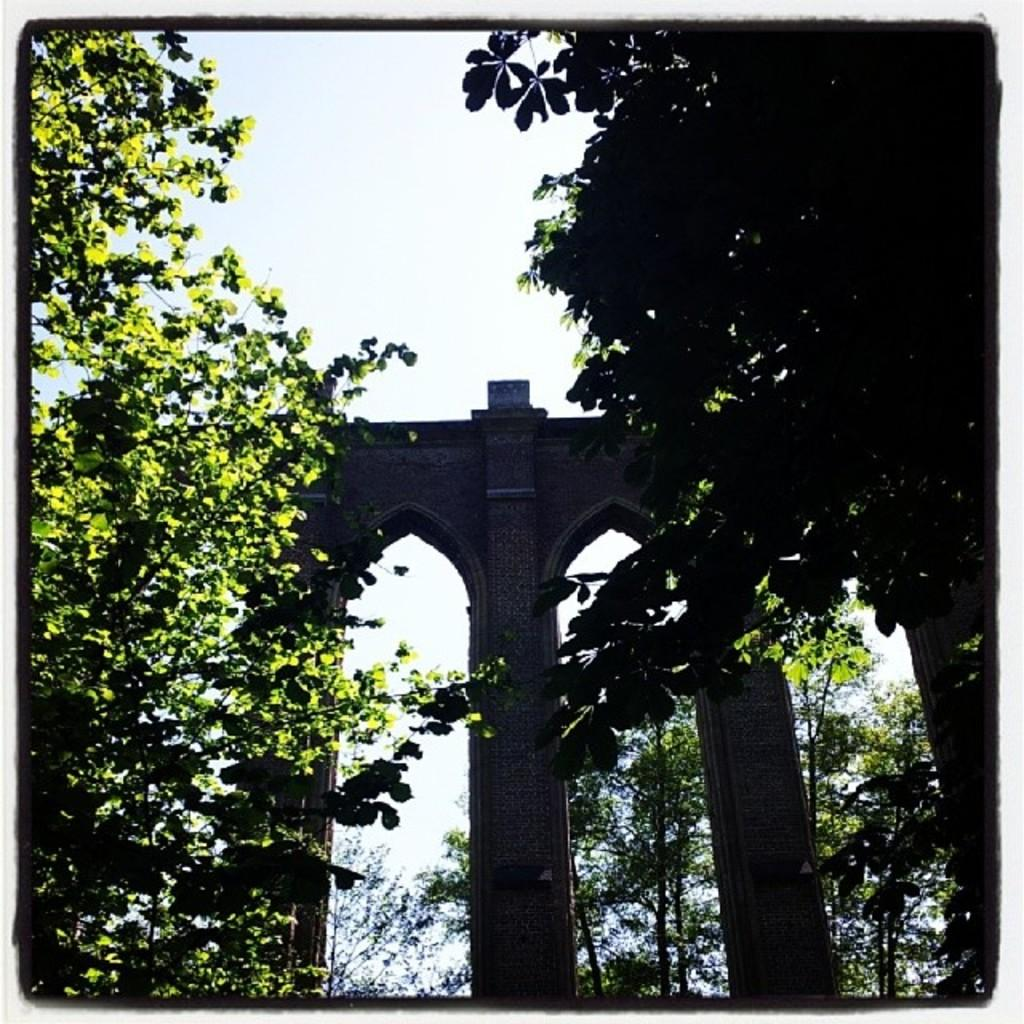What type of structure is present in the image? There is an arch in the image. What type of vegetation can be seen in the image? There are trees in the image. What is the condition of the sky in the image? The sky is clear in the image. What does the caption say about the arch in the image? There is no caption present in the image, so it is not possible to answer that question. How much heat can be felt from the arch in the image? The image does not provide any information about the temperature or heat, so it is not possible to answer that question. 